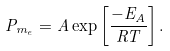<formula> <loc_0><loc_0><loc_500><loc_500>P _ { m _ { e } } = A \exp \left [ \frac { - E _ { A } } { R T } \right ] .</formula> 